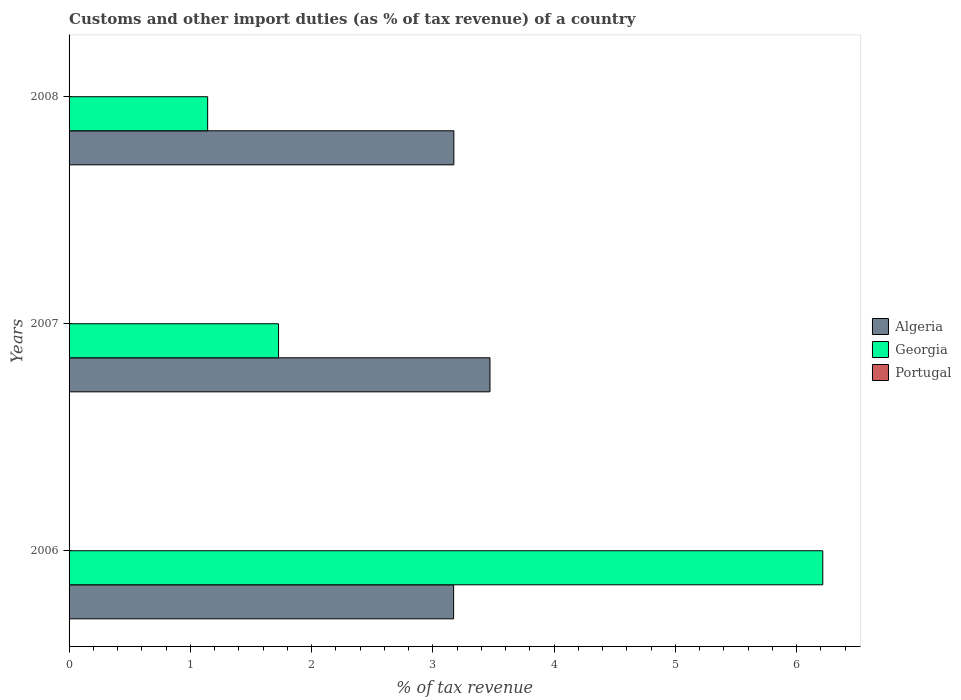How many groups of bars are there?
Provide a succinct answer. 3. Are the number of bars per tick equal to the number of legend labels?
Ensure brevity in your answer.  Yes. Are the number of bars on each tick of the Y-axis equal?
Your response must be concise. Yes. How many bars are there on the 3rd tick from the top?
Provide a short and direct response. 3. What is the label of the 1st group of bars from the top?
Offer a terse response. 2008. What is the percentage of tax revenue from customs in Portugal in 2008?
Your answer should be very brief. 0. Across all years, what is the maximum percentage of tax revenue from customs in Georgia?
Offer a terse response. 6.22. Across all years, what is the minimum percentage of tax revenue from customs in Portugal?
Make the answer very short. 0. In which year was the percentage of tax revenue from customs in Portugal minimum?
Ensure brevity in your answer.  2006. What is the total percentage of tax revenue from customs in Algeria in the graph?
Your response must be concise. 9.81. What is the difference between the percentage of tax revenue from customs in Portugal in 2006 and that in 2008?
Provide a short and direct response. -0. What is the difference between the percentage of tax revenue from customs in Algeria in 2006 and the percentage of tax revenue from customs in Portugal in 2007?
Your answer should be very brief. 3.17. What is the average percentage of tax revenue from customs in Portugal per year?
Keep it short and to the point. 0. In the year 2007, what is the difference between the percentage of tax revenue from customs in Portugal and percentage of tax revenue from customs in Algeria?
Provide a succinct answer. -3.47. In how many years, is the percentage of tax revenue from customs in Georgia greater than 5.4 %?
Give a very brief answer. 1. What is the ratio of the percentage of tax revenue from customs in Algeria in 2006 to that in 2007?
Offer a terse response. 0.91. Is the percentage of tax revenue from customs in Portugal in 2007 less than that in 2008?
Keep it short and to the point. Yes. What is the difference between the highest and the second highest percentage of tax revenue from customs in Algeria?
Ensure brevity in your answer.  0.3. What is the difference between the highest and the lowest percentage of tax revenue from customs in Algeria?
Make the answer very short. 0.3. In how many years, is the percentage of tax revenue from customs in Georgia greater than the average percentage of tax revenue from customs in Georgia taken over all years?
Give a very brief answer. 1. Is the sum of the percentage of tax revenue from customs in Georgia in 2007 and 2008 greater than the maximum percentage of tax revenue from customs in Portugal across all years?
Offer a terse response. Yes. What does the 3rd bar from the top in 2007 represents?
Your response must be concise. Algeria. Is it the case that in every year, the sum of the percentage of tax revenue from customs in Algeria and percentage of tax revenue from customs in Georgia is greater than the percentage of tax revenue from customs in Portugal?
Your response must be concise. Yes. How many bars are there?
Make the answer very short. 9. How many years are there in the graph?
Provide a short and direct response. 3. What is the difference between two consecutive major ticks on the X-axis?
Offer a terse response. 1. Does the graph contain any zero values?
Offer a very short reply. No. Where does the legend appear in the graph?
Your answer should be very brief. Center right. How are the legend labels stacked?
Provide a succinct answer. Vertical. What is the title of the graph?
Offer a very short reply. Customs and other import duties (as % of tax revenue) of a country. What is the label or title of the X-axis?
Offer a very short reply. % of tax revenue. What is the % of tax revenue in Algeria in 2006?
Ensure brevity in your answer.  3.17. What is the % of tax revenue in Georgia in 2006?
Your answer should be compact. 6.22. What is the % of tax revenue of Portugal in 2006?
Offer a very short reply. 0. What is the % of tax revenue in Algeria in 2007?
Provide a short and direct response. 3.47. What is the % of tax revenue in Georgia in 2007?
Offer a terse response. 1.73. What is the % of tax revenue of Portugal in 2007?
Provide a short and direct response. 0. What is the % of tax revenue of Algeria in 2008?
Ensure brevity in your answer.  3.17. What is the % of tax revenue of Georgia in 2008?
Your response must be concise. 1.14. What is the % of tax revenue of Portugal in 2008?
Offer a very short reply. 0. Across all years, what is the maximum % of tax revenue of Algeria?
Provide a short and direct response. 3.47. Across all years, what is the maximum % of tax revenue in Georgia?
Offer a terse response. 6.22. Across all years, what is the maximum % of tax revenue in Portugal?
Your response must be concise. 0. Across all years, what is the minimum % of tax revenue of Algeria?
Make the answer very short. 3.17. Across all years, what is the minimum % of tax revenue of Georgia?
Your answer should be compact. 1.14. Across all years, what is the minimum % of tax revenue of Portugal?
Your answer should be compact. 0. What is the total % of tax revenue in Algeria in the graph?
Offer a terse response. 9.81. What is the total % of tax revenue in Georgia in the graph?
Give a very brief answer. 9.09. What is the total % of tax revenue of Portugal in the graph?
Keep it short and to the point. 0.01. What is the difference between the % of tax revenue of Algeria in 2006 and that in 2007?
Offer a very short reply. -0.3. What is the difference between the % of tax revenue of Georgia in 2006 and that in 2007?
Your answer should be compact. 4.49. What is the difference between the % of tax revenue in Portugal in 2006 and that in 2007?
Give a very brief answer. -0. What is the difference between the % of tax revenue in Algeria in 2006 and that in 2008?
Offer a terse response. -0. What is the difference between the % of tax revenue in Georgia in 2006 and that in 2008?
Offer a terse response. 5.07. What is the difference between the % of tax revenue of Portugal in 2006 and that in 2008?
Keep it short and to the point. -0. What is the difference between the % of tax revenue in Algeria in 2007 and that in 2008?
Make the answer very short. 0.3. What is the difference between the % of tax revenue of Georgia in 2007 and that in 2008?
Your answer should be very brief. 0.58. What is the difference between the % of tax revenue in Portugal in 2007 and that in 2008?
Give a very brief answer. -0. What is the difference between the % of tax revenue of Algeria in 2006 and the % of tax revenue of Georgia in 2007?
Give a very brief answer. 1.44. What is the difference between the % of tax revenue in Algeria in 2006 and the % of tax revenue in Portugal in 2007?
Offer a terse response. 3.17. What is the difference between the % of tax revenue in Georgia in 2006 and the % of tax revenue in Portugal in 2007?
Keep it short and to the point. 6.21. What is the difference between the % of tax revenue in Algeria in 2006 and the % of tax revenue in Georgia in 2008?
Keep it short and to the point. 2.03. What is the difference between the % of tax revenue in Algeria in 2006 and the % of tax revenue in Portugal in 2008?
Give a very brief answer. 3.17. What is the difference between the % of tax revenue in Georgia in 2006 and the % of tax revenue in Portugal in 2008?
Make the answer very short. 6.21. What is the difference between the % of tax revenue in Algeria in 2007 and the % of tax revenue in Georgia in 2008?
Offer a very short reply. 2.33. What is the difference between the % of tax revenue of Algeria in 2007 and the % of tax revenue of Portugal in 2008?
Provide a short and direct response. 3.47. What is the difference between the % of tax revenue of Georgia in 2007 and the % of tax revenue of Portugal in 2008?
Your answer should be very brief. 1.72. What is the average % of tax revenue of Algeria per year?
Your response must be concise. 3.27. What is the average % of tax revenue in Georgia per year?
Offer a terse response. 3.03. What is the average % of tax revenue of Portugal per year?
Provide a succinct answer. 0. In the year 2006, what is the difference between the % of tax revenue in Algeria and % of tax revenue in Georgia?
Keep it short and to the point. -3.04. In the year 2006, what is the difference between the % of tax revenue of Algeria and % of tax revenue of Portugal?
Make the answer very short. 3.17. In the year 2006, what is the difference between the % of tax revenue in Georgia and % of tax revenue in Portugal?
Your answer should be very brief. 6.21. In the year 2007, what is the difference between the % of tax revenue in Algeria and % of tax revenue in Georgia?
Give a very brief answer. 1.74. In the year 2007, what is the difference between the % of tax revenue in Algeria and % of tax revenue in Portugal?
Your answer should be very brief. 3.47. In the year 2007, what is the difference between the % of tax revenue of Georgia and % of tax revenue of Portugal?
Your response must be concise. 1.72. In the year 2008, what is the difference between the % of tax revenue of Algeria and % of tax revenue of Georgia?
Your answer should be very brief. 2.03. In the year 2008, what is the difference between the % of tax revenue of Algeria and % of tax revenue of Portugal?
Offer a terse response. 3.17. In the year 2008, what is the difference between the % of tax revenue in Georgia and % of tax revenue in Portugal?
Provide a succinct answer. 1.14. What is the ratio of the % of tax revenue of Algeria in 2006 to that in 2007?
Give a very brief answer. 0.91. What is the ratio of the % of tax revenue in Georgia in 2006 to that in 2007?
Provide a short and direct response. 3.6. What is the ratio of the % of tax revenue in Portugal in 2006 to that in 2007?
Your answer should be very brief. 0.53. What is the ratio of the % of tax revenue in Georgia in 2006 to that in 2008?
Keep it short and to the point. 5.44. What is the ratio of the % of tax revenue of Portugal in 2006 to that in 2008?
Provide a succinct answer. 0.43. What is the ratio of the % of tax revenue of Algeria in 2007 to that in 2008?
Provide a short and direct response. 1.09. What is the ratio of the % of tax revenue in Georgia in 2007 to that in 2008?
Offer a terse response. 1.51. What is the ratio of the % of tax revenue in Portugal in 2007 to that in 2008?
Ensure brevity in your answer.  0.82. What is the difference between the highest and the second highest % of tax revenue in Algeria?
Provide a short and direct response. 0.3. What is the difference between the highest and the second highest % of tax revenue in Georgia?
Provide a short and direct response. 4.49. What is the difference between the highest and the lowest % of tax revenue of Algeria?
Give a very brief answer. 0.3. What is the difference between the highest and the lowest % of tax revenue of Georgia?
Your response must be concise. 5.07. What is the difference between the highest and the lowest % of tax revenue of Portugal?
Give a very brief answer. 0. 